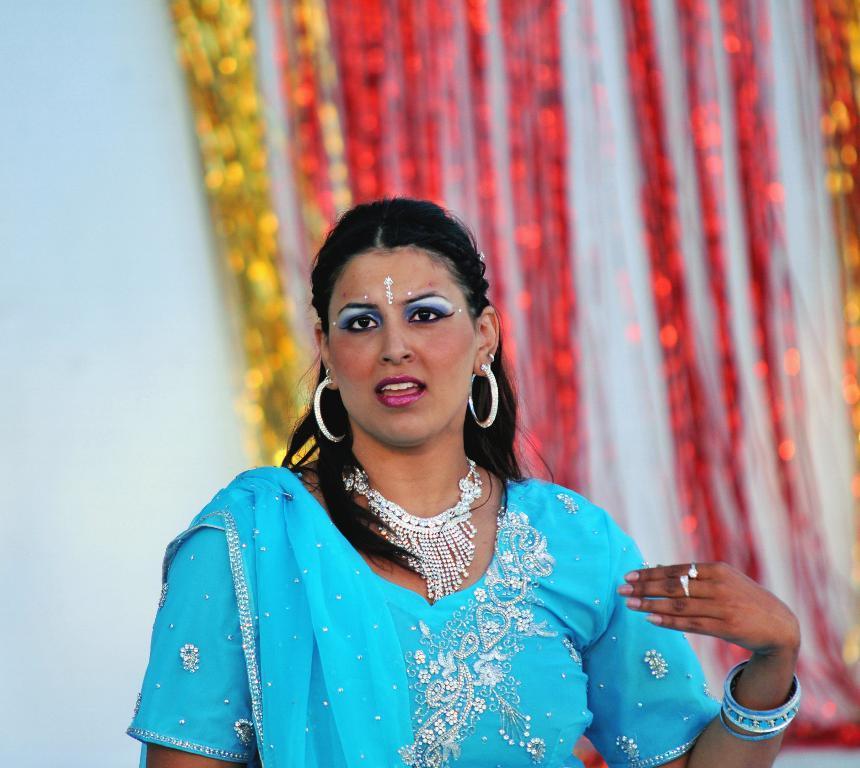In one or two sentences, can you explain what this image depicts? In this image we can see a person with a blue color dress, in the background wecan see a curtain and a wall. 